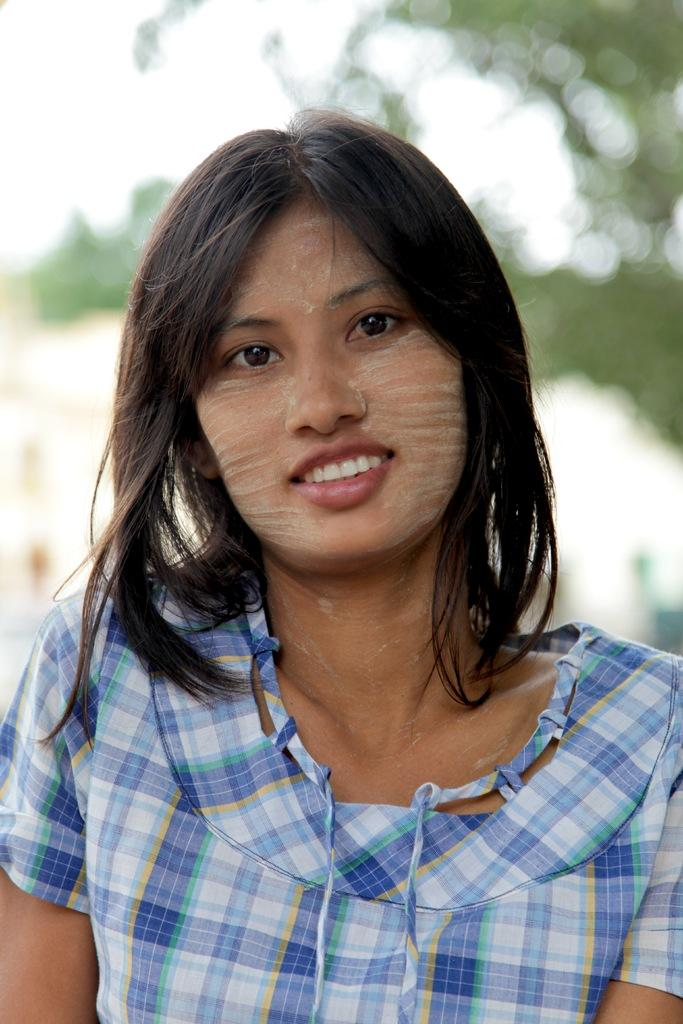What is the main subject of the image? There is a person in the image. What is the person wearing? The person is wearing a dress. Can you describe the background of the image? The background of the image is blurred. How many passengers are visible in the image? There is no reference to passengers in the image, as it only features a person wearing a dress. 